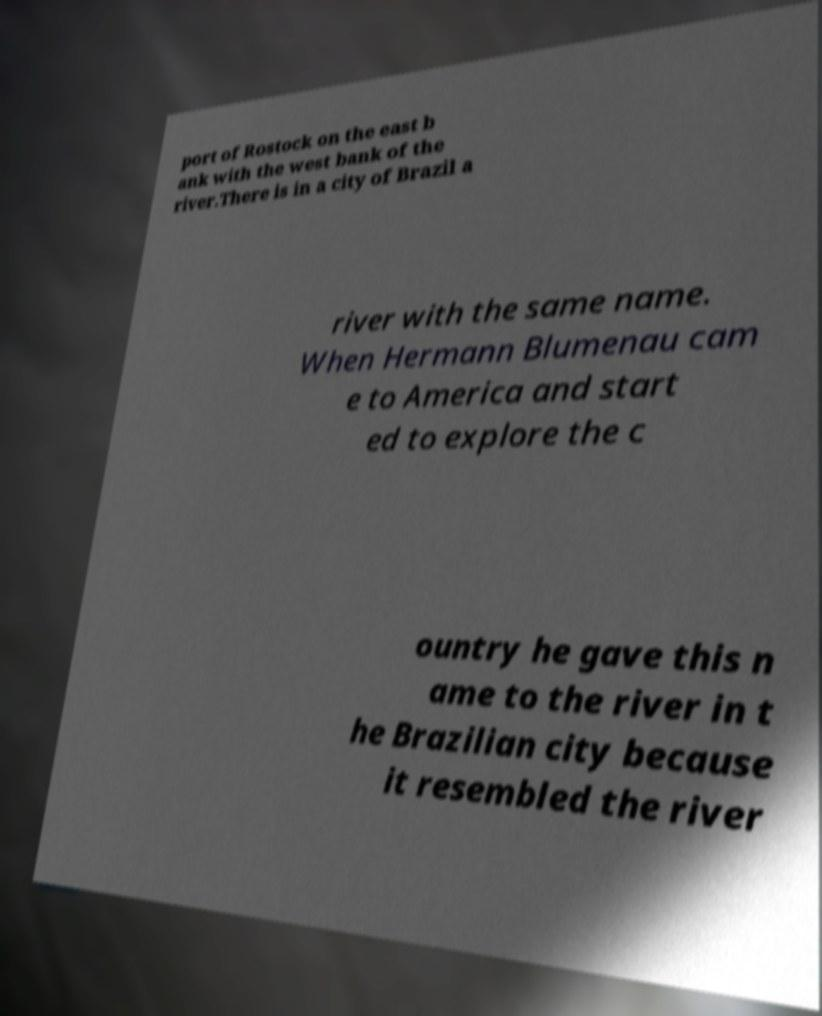I need the written content from this picture converted into text. Can you do that? port of Rostock on the east b ank with the west bank of the river.There is in a city of Brazil a river with the same name. When Hermann Blumenau cam e to America and start ed to explore the c ountry he gave this n ame to the river in t he Brazilian city because it resembled the river 